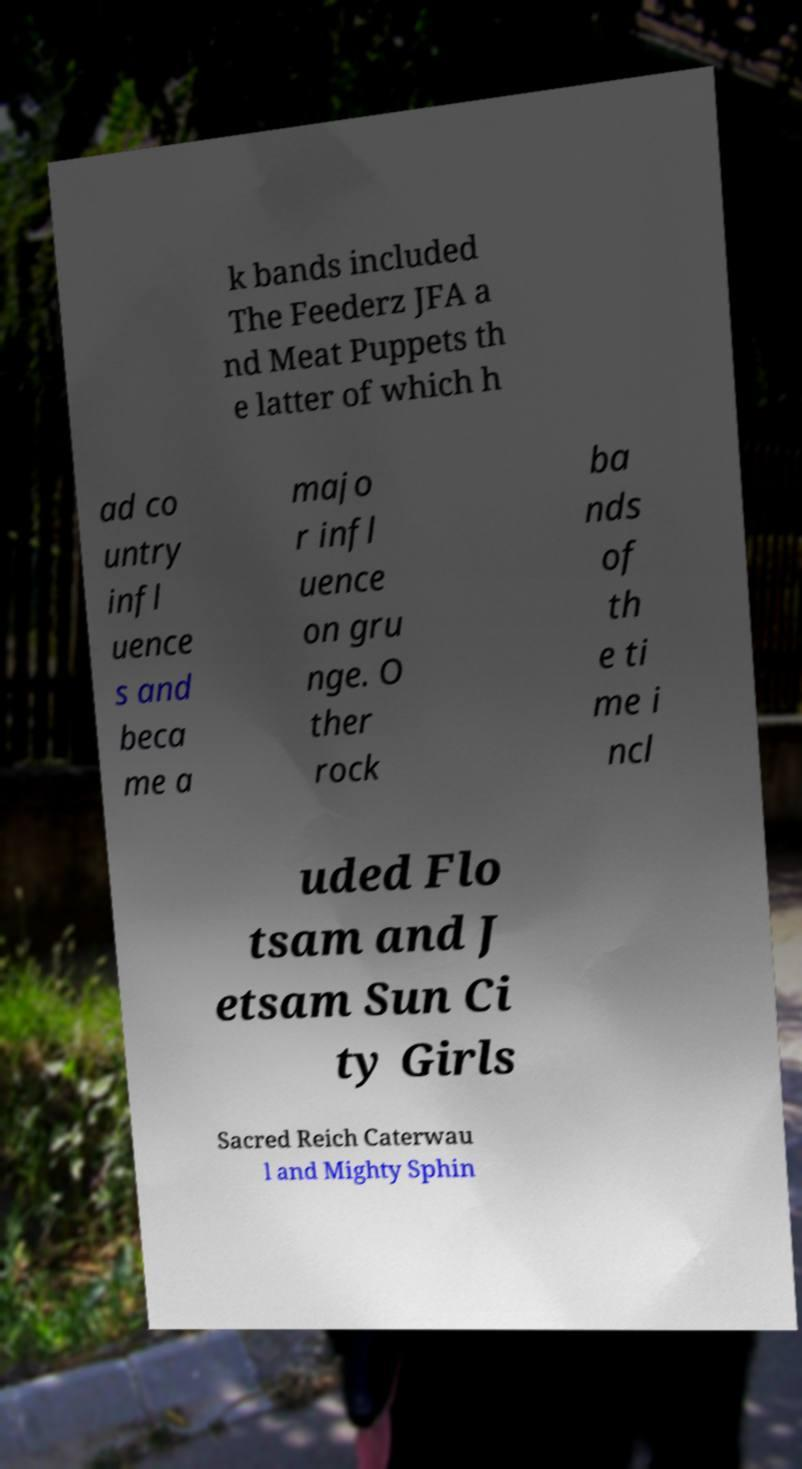Could you assist in decoding the text presented in this image and type it out clearly? k bands included The Feederz JFA a nd Meat Puppets th e latter of which h ad co untry infl uence s and beca me a majo r infl uence on gru nge. O ther rock ba nds of th e ti me i ncl uded Flo tsam and J etsam Sun Ci ty Girls Sacred Reich Caterwau l and Mighty Sphin 